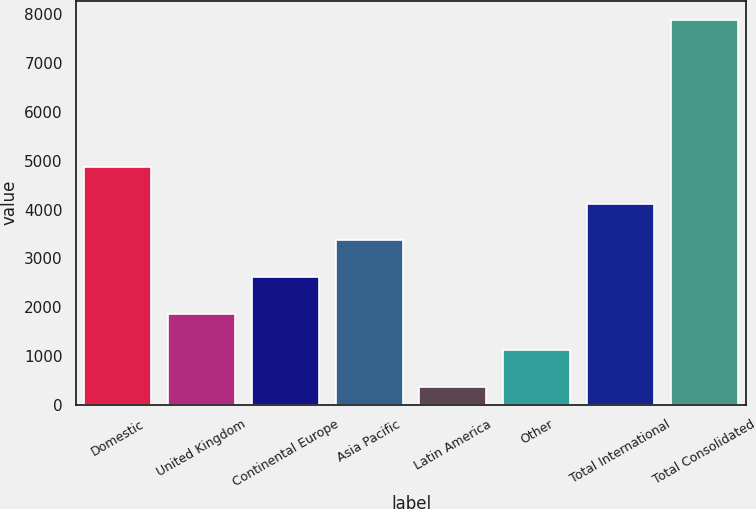Convert chart. <chart><loc_0><loc_0><loc_500><loc_500><bar_chart><fcel>Domestic<fcel>United Kingdom<fcel>Continental Europe<fcel>Asia Pacific<fcel>Latin America<fcel>Other<fcel>Total International<fcel>Total Consolidated<nl><fcel>4871.8<fcel>1861.2<fcel>2613.85<fcel>3366.5<fcel>355.9<fcel>1108.55<fcel>4119.15<fcel>7882.4<nl></chart> 